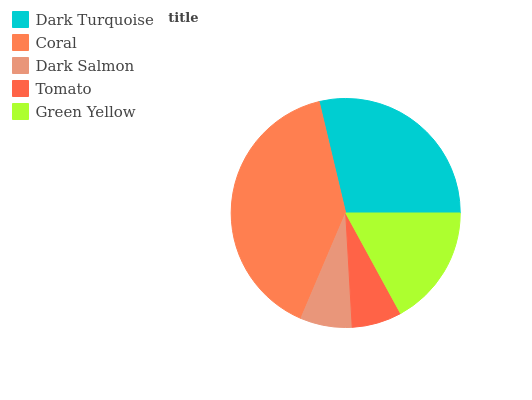Is Tomato the minimum?
Answer yes or no. Yes. Is Coral the maximum?
Answer yes or no. Yes. Is Dark Salmon the minimum?
Answer yes or no. No. Is Dark Salmon the maximum?
Answer yes or no. No. Is Coral greater than Dark Salmon?
Answer yes or no. Yes. Is Dark Salmon less than Coral?
Answer yes or no. Yes. Is Dark Salmon greater than Coral?
Answer yes or no. No. Is Coral less than Dark Salmon?
Answer yes or no. No. Is Green Yellow the high median?
Answer yes or no. Yes. Is Green Yellow the low median?
Answer yes or no. Yes. Is Dark Turquoise the high median?
Answer yes or no. No. Is Tomato the low median?
Answer yes or no. No. 